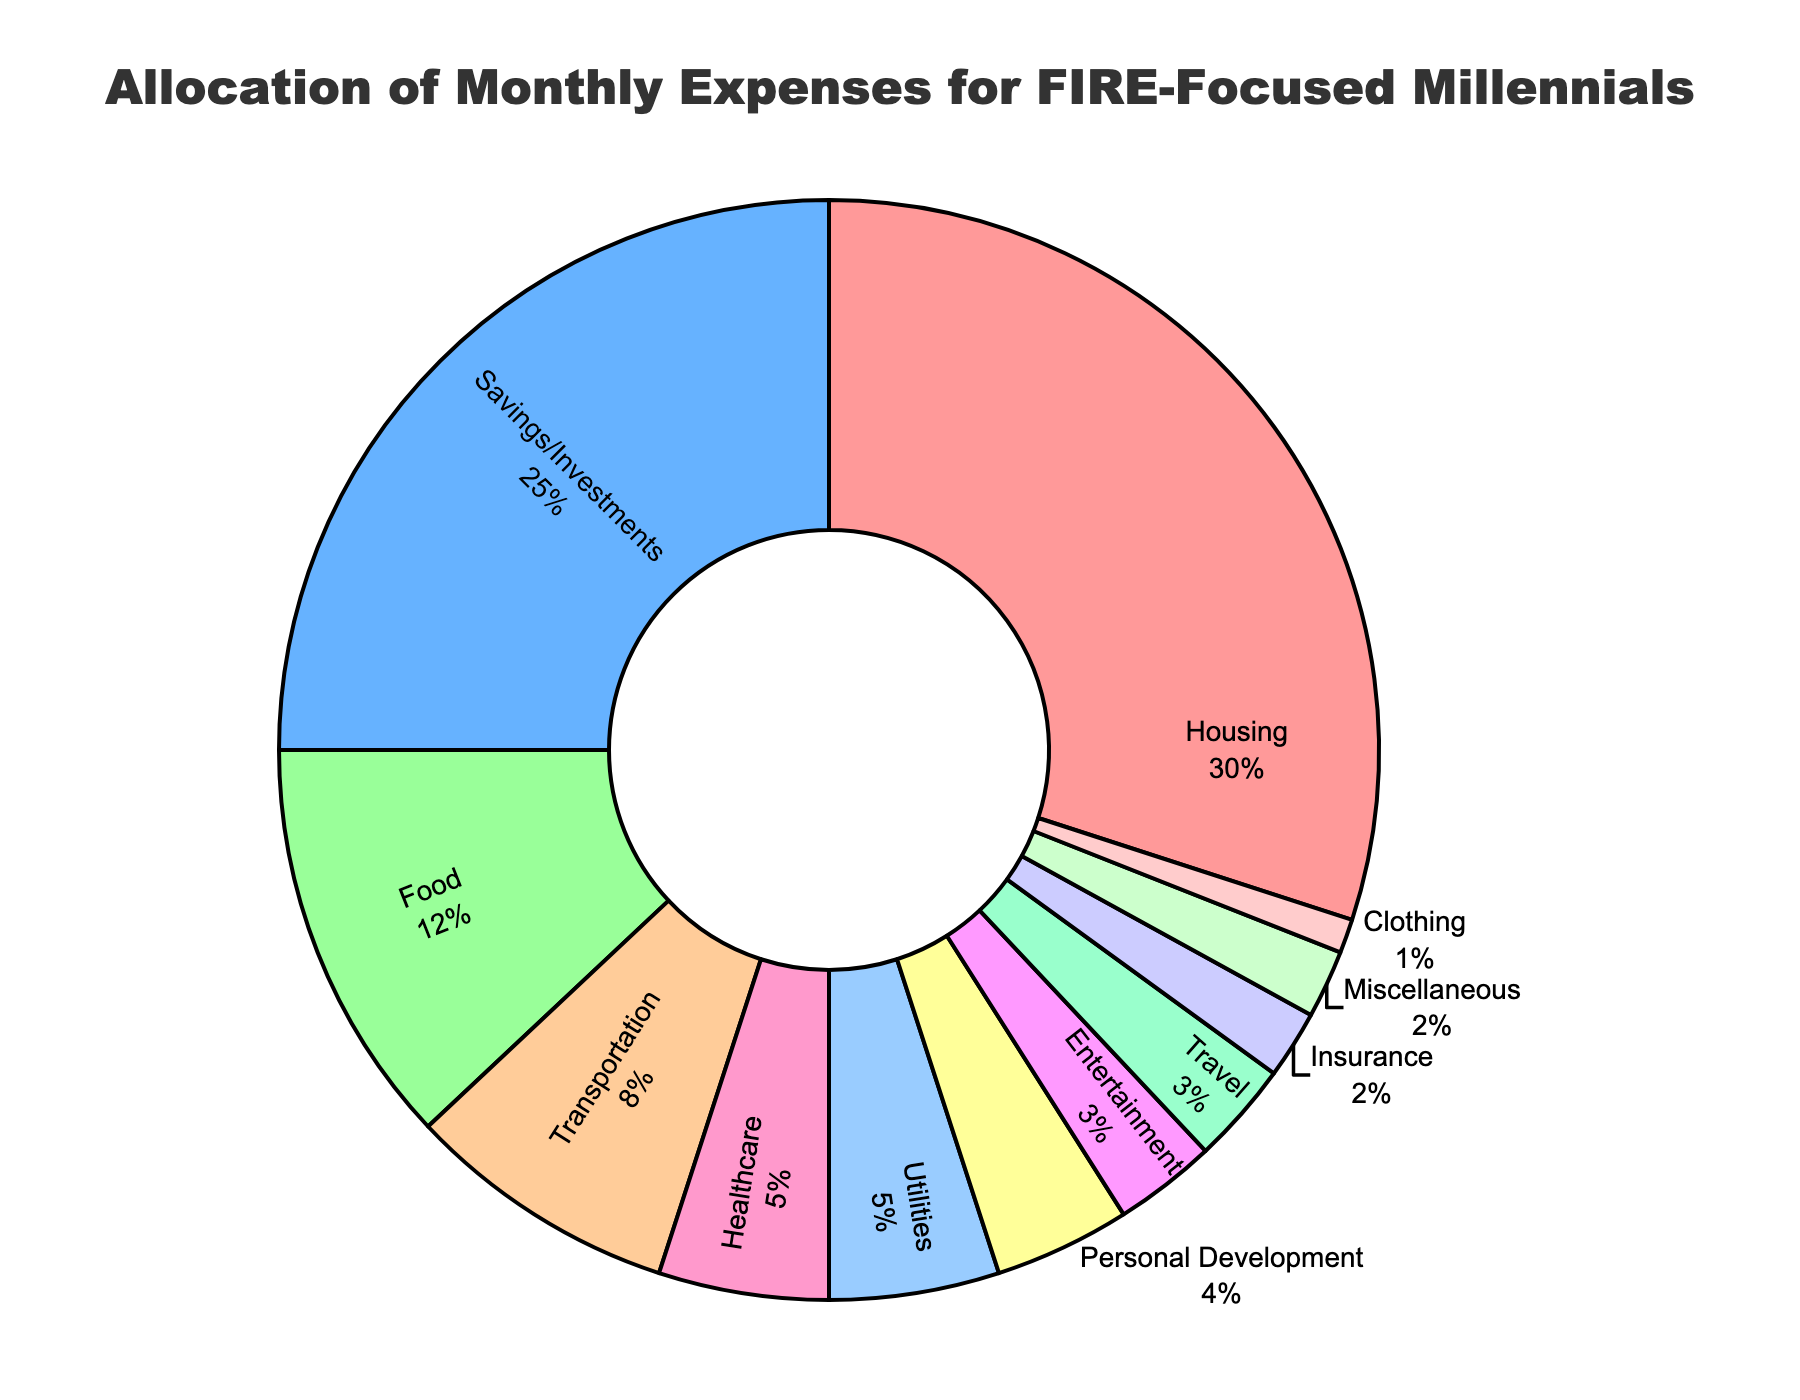what is the largest spending category? the category with the highest percentage value represents the largest spending. here, housing has the highest percentage of 30%
Answer: housing how much higher is the percentage for Housing compared to Food? subtract the percentage of food from that of housing (30% - 12% = 18%)
Answer: 18% which two categories have the smallest allocation percentages? the two categories with the lowest percentage values are insurance (2%) and clothing (1%)
Answer: insurance and clothing what is the combined percentage allocation for travel and entertainment? add the percentages of travel and entertainment (3% + 3% = 6%)
Answer: 6% which categories together make up more than half of the expenses? add the percentages until the sum exceeds 50%. (housing 30% + savings/investments 25% = 55%)
Answer: housing and savings/investments how does the allocation for transportation compare to that for healthcare? the percentage allocated to transportation (8%) is higher than that for healthcare (5%)
Answer: transportation is higher what percent of the total monthly expenses are allocated to non-essential categories (clothing, entertainment, travel, and miscellaneous)? sum the percentages of clothing, entertainment, travel, and miscellaneous (1% + 3% + 3% + 2% = 9%)
Answer: 9% if an individual wants to save more and decides to cut the personal development budget by half, what percentage will this free up for savings? cutting the personal development budget in half frees up 2% (4% / 2 = 2%)
Answer: 2% 